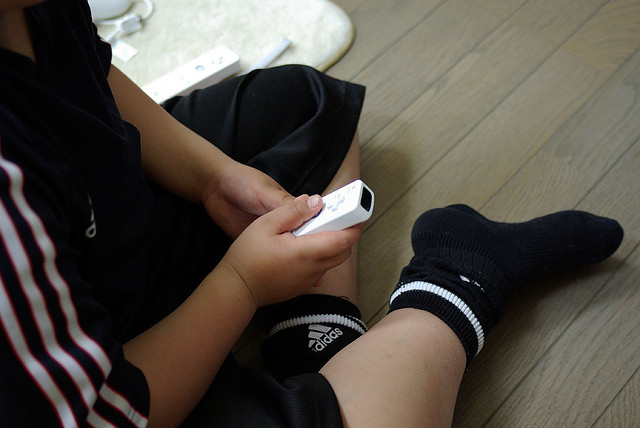Identify the text displayed in this image. aid 